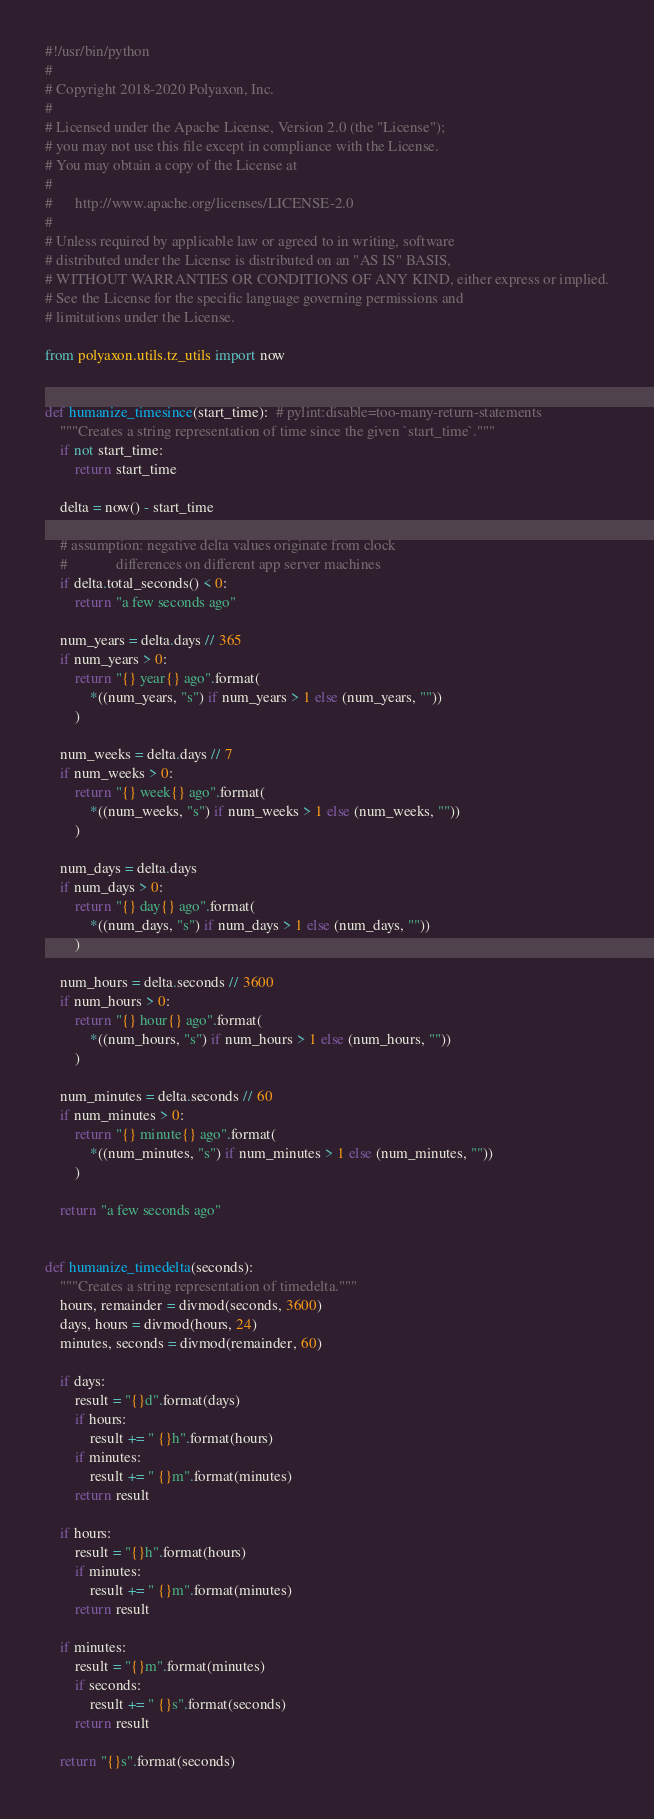Convert code to text. <code><loc_0><loc_0><loc_500><loc_500><_Python_>#!/usr/bin/python
#
# Copyright 2018-2020 Polyaxon, Inc.
#
# Licensed under the Apache License, Version 2.0 (the "License");
# you may not use this file except in compliance with the License.
# You may obtain a copy of the License at
#
#      http://www.apache.org/licenses/LICENSE-2.0
#
# Unless required by applicable law or agreed to in writing, software
# distributed under the License is distributed on an "AS IS" BASIS,
# WITHOUT WARRANTIES OR CONDITIONS OF ANY KIND, either express or implied.
# See the License for the specific language governing permissions and
# limitations under the License.

from polyaxon.utils.tz_utils import now


def humanize_timesince(start_time):  # pylint:disable=too-many-return-statements
    """Creates a string representation of time since the given `start_time`."""
    if not start_time:
        return start_time

    delta = now() - start_time

    # assumption: negative delta values originate from clock
    #             differences on different app server machines
    if delta.total_seconds() < 0:
        return "a few seconds ago"

    num_years = delta.days // 365
    if num_years > 0:
        return "{} year{} ago".format(
            *((num_years, "s") if num_years > 1 else (num_years, ""))
        )

    num_weeks = delta.days // 7
    if num_weeks > 0:
        return "{} week{} ago".format(
            *((num_weeks, "s") if num_weeks > 1 else (num_weeks, ""))
        )

    num_days = delta.days
    if num_days > 0:
        return "{} day{} ago".format(
            *((num_days, "s") if num_days > 1 else (num_days, ""))
        )

    num_hours = delta.seconds // 3600
    if num_hours > 0:
        return "{} hour{} ago".format(
            *((num_hours, "s") if num_hours > 1 else (num_hours, ""))
        )

    num_minutes = delta.seconds // 60
    if num_minutes > 0:
        return "{} minute{} ago".format(
            *((num_minutes, "s") if num_minutes > 1 else (num_minutes, ""))
        )

    return "a few seconds ago"


def humanize_timedelta(seconds):
    """Creates a string representation of timedelta."""
    hours, remainder = divmod(seconds, 3600)
    days, hours = divmod(hours, 24)
    minutes, seconds = divmod(remainder, 60)

    if days:
        result = "{}d".format(days)
        if hours:
            result += " {}h".format(hours)
        if minutes:
            result += " {}m".format(minutes)
        return result

    if hours:
        result = "{}h".format(hours)
        if minutes:
            result += " {}m".format(minutes)
        return result

    if minutes:
        result = "{}m".format(minutes)
        if seconds:
            result += " {}s".format(seconds)
        return result

    return "{}s".format(seconds)
</code> 